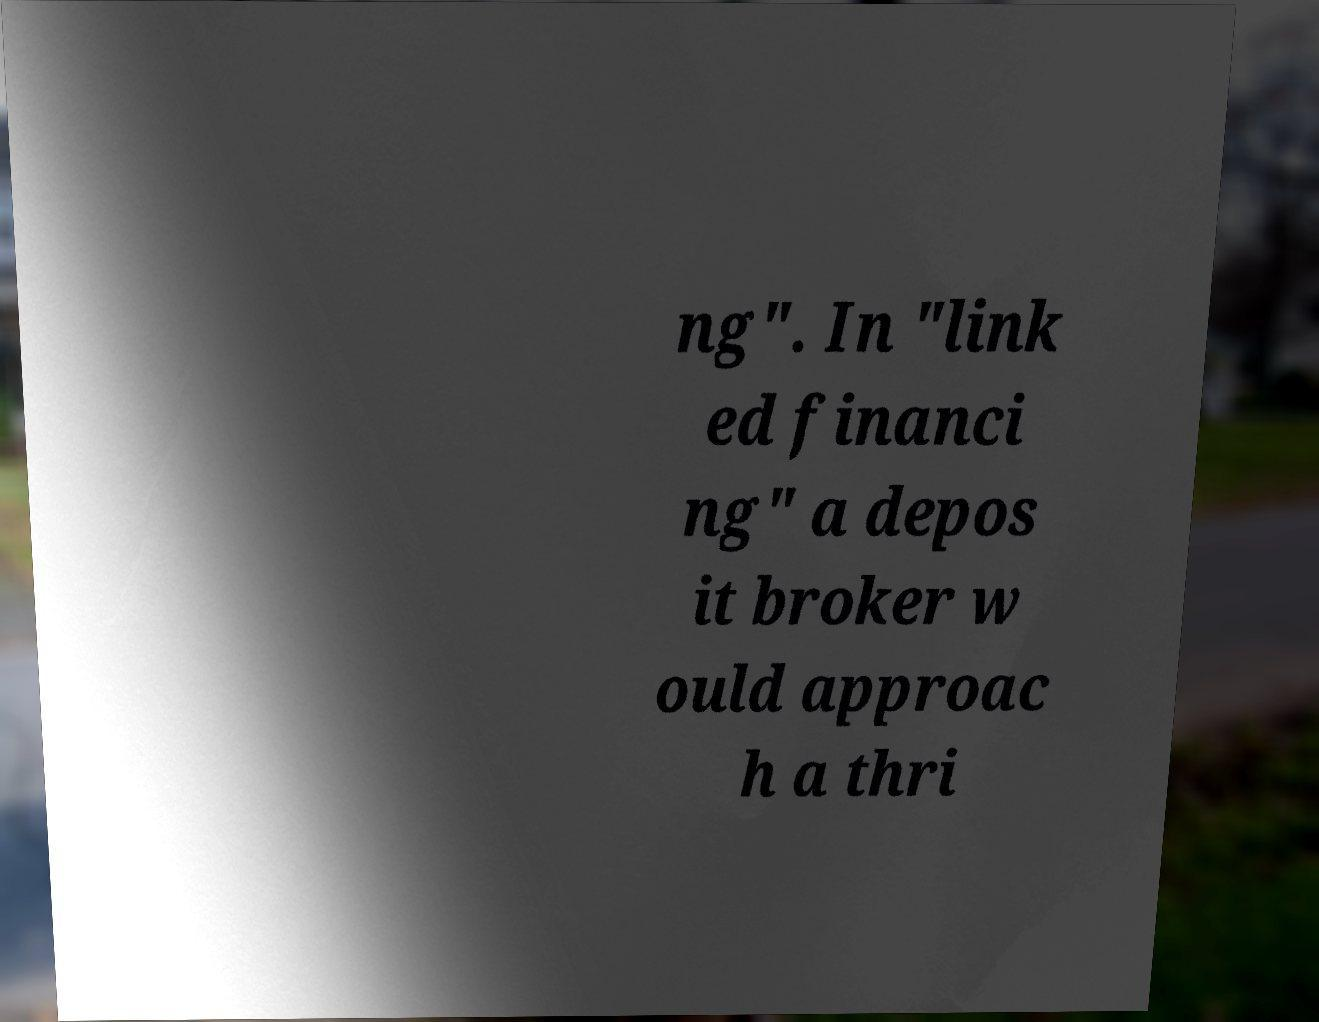Please identify and transcribe the text found in this image. ng". In "link ed financi ng" a depos it broker w ould approac h a thri 